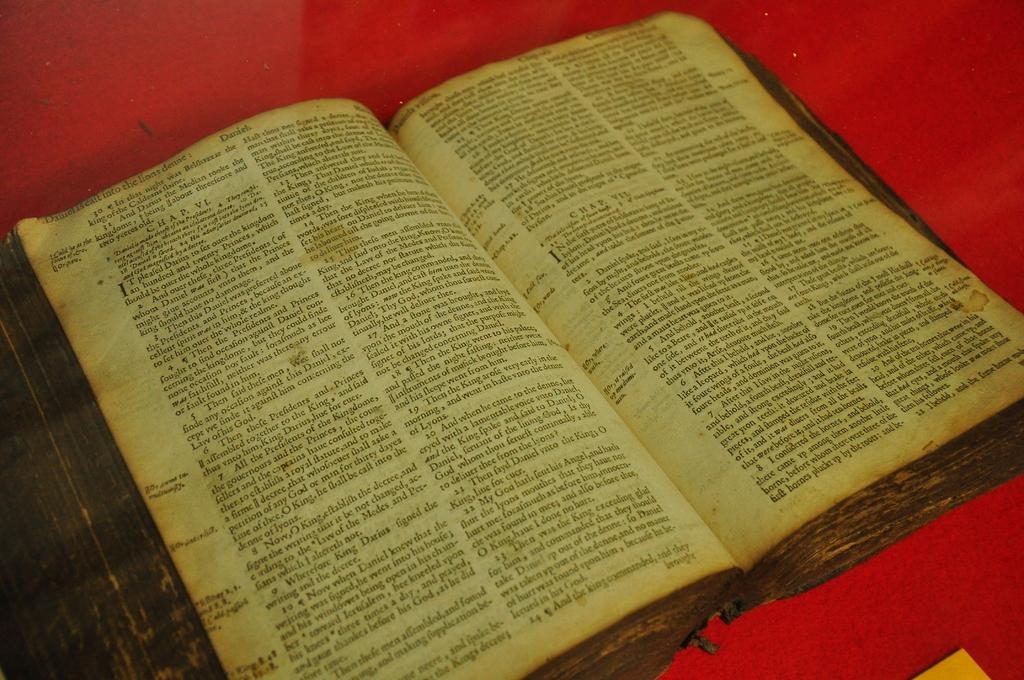<image>
Render a clear and concise summary of the photo. An open book which first line reads " Daniel is calt into the lions denne". 